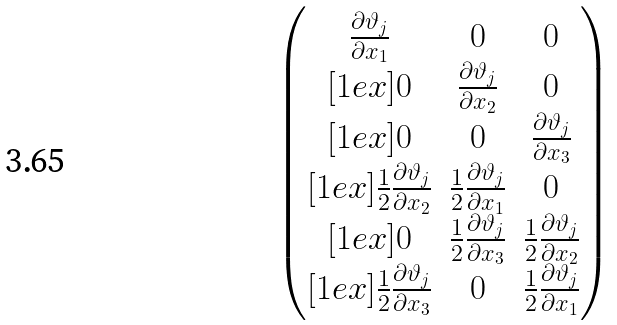<formula> <loc_0><loc_0><loc_500><loc_500>\begin{pmatrix} \frac { \partial \vartheta _ { j } } { \partial x _ { 1 } } & 0 & 0 \\ [ 1 e x ] 0 & \frac { \partial \vartheta _ { j } } { \partial x _ { 2 } } & 0 \\ [ 1 e x ] 0 & 0 & \frac { \partial \vartheta _ { j } } { \partial x _ { 3 } } \\ [ 1 e x ] \frac { 1 } { 2 } \frac { \partial \vartheta _ { j } } { \partial x _ { 2 } } & \frac { 1 } { 2 } \frac { \partial \vartheta _ { j } } { \partial x _ { 1 } } & 0 \\ [ 1 e x ] 0 & \frac { 1 } { 2 } \frac { \partial \vartheta _ { j } } { \partial x _ { 3 } } & \frac { 1 } { 2 } \frac { \partial \vartheta _ { j } } { \partial x _ { 2 } } \\ [ 1 e x ] \frac { 1 } { 2 } \frac { \partial \vartheta _ { j } } { \partial x _ { 3 } } & 0 & \frac { 1 } { 2 } \frac { \partial \vartheta _ { j } } { \partial x _ { 1 } } \end{pmatrix}</formula> 